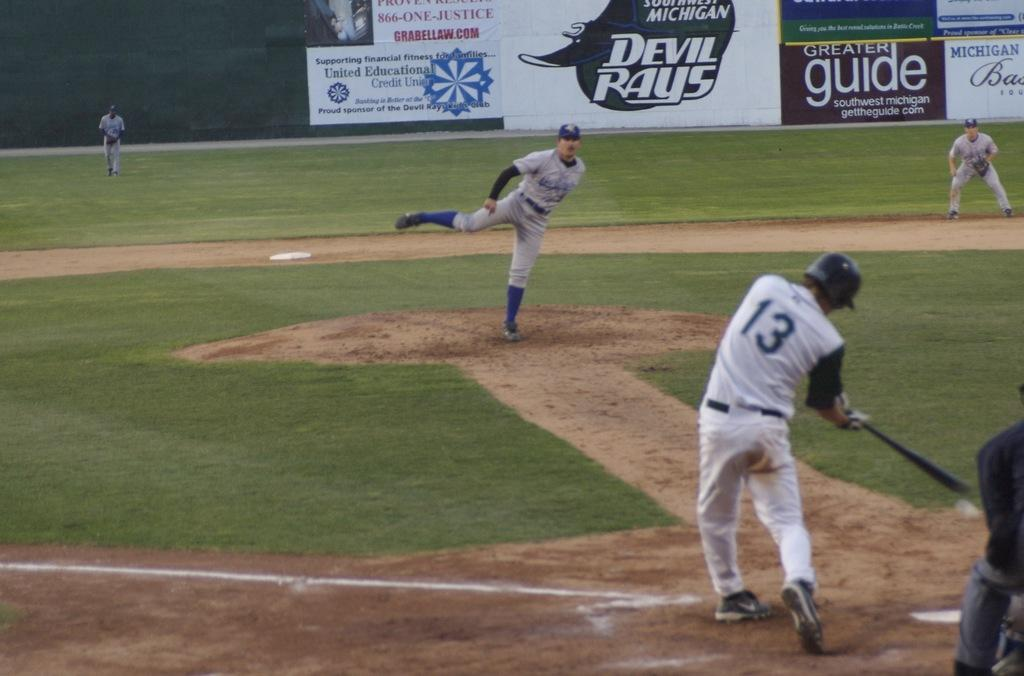What sport are the people playing in the image? The people are playing baseball in the image. Where is the baseball game taking place? The baseball game is taking place on a ground. What can be seen in the background of the image? There are banners visible in the background of the image. What type of nose is the umpire wearing in the image? There is no umpire or nose present in the image; it features people playing baseball on a ground with banners in the background. 